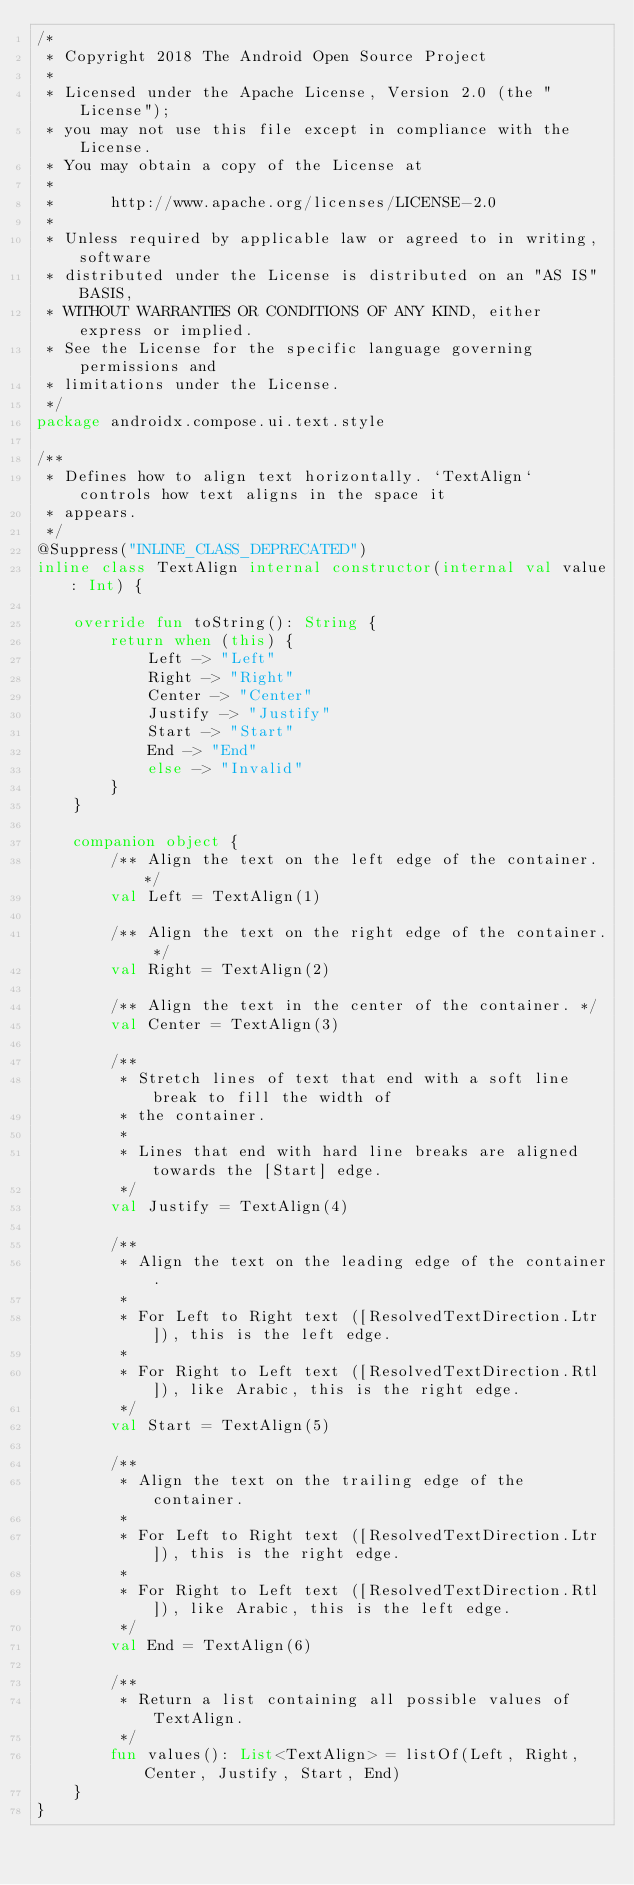<code> <loc_0><loc_0><loc_500><loc_500><_Kotlin_>/*
 * Copyright 2018 The Android Open Source Project
 *
 * Licensed under the Apache License, Version 2.0 (the "License");
 * you may not use this file except in compliance with the License.
 * You may obtain a copy of the License at
 *
 *      http://www.apache.org/licenses/LICENSE-2.0
 *
 * Unless required by applicable law or agreed to in writing, software
 * distributed under the License is distributed on an "AS IS" BASIS,
 * WITHOUT WARRANTIES OR CONDITIONS OF ANY KIND, either express or implied.
 * See the License for the specific language governing permissions and
 * limitations under the License.
 */
package androidx.compose.ui.text.style

/**
 * Defines how to align text horizontally. `TextAlign` controls how text aligns in the space it
 * appears.
 */
@Suppress("INLINE_CLASS_DEPRECATED")
inline class TextAlign internal constructor(internal val value: Int) {

    override fun toString(): String {
        return when (this) {
            Left -> "Left"
            Right -> "Right"
            Center -> "Center"
            Justify -> "Justify"
            Start -> "Start"
            End -> "End"
            else -> "Invalid"
        }
    }

    companion object {
        /** Align the text on the left edge of the container. */
        val Left = TextAlign(1)

        /** Align the text on the right edge of the container. */
        val Right = TextAlign(2)

        /** Align the text in the center of the container. */
        val Center = TextAlign(3)

        /**
         * Stretch lines of text that end with a soft line break to fill the width of
         * the container.
         *
         * Lines that end with hard line breaks are aligned towards the [Start] edge.
         */
        val Justify = TextAlign(4)

        /**
         * Align the text on the leading edge of the container.
         *
         * For Left to Right text ([ResolvedTextDirection.Ltr]), this is the left edge.
         *
         * For Right to Left text ([ResolvedTextDirection.Rtl]), like Arabic, this is the right edge.
         */
        val Start = TextAlign(5)

        /**
         * Align the text on the trailing edge of the container.
         *
         * For Left to Right text ([ResolvedTextDirection.Ltr]), this is the right edge.
         *
         * For Right to Left text ([ResolvedTextDirection.Rtl]), like Arabic, this is the left edge.
         */
        val End = TextAlign(6)

        /**
         * Return a list containing all possible values of TextAlign.
         */
        fun values(): List<TextAlign> = listOf(Left, Right, Center, Justify, Start, End)
    }
}
</code> 